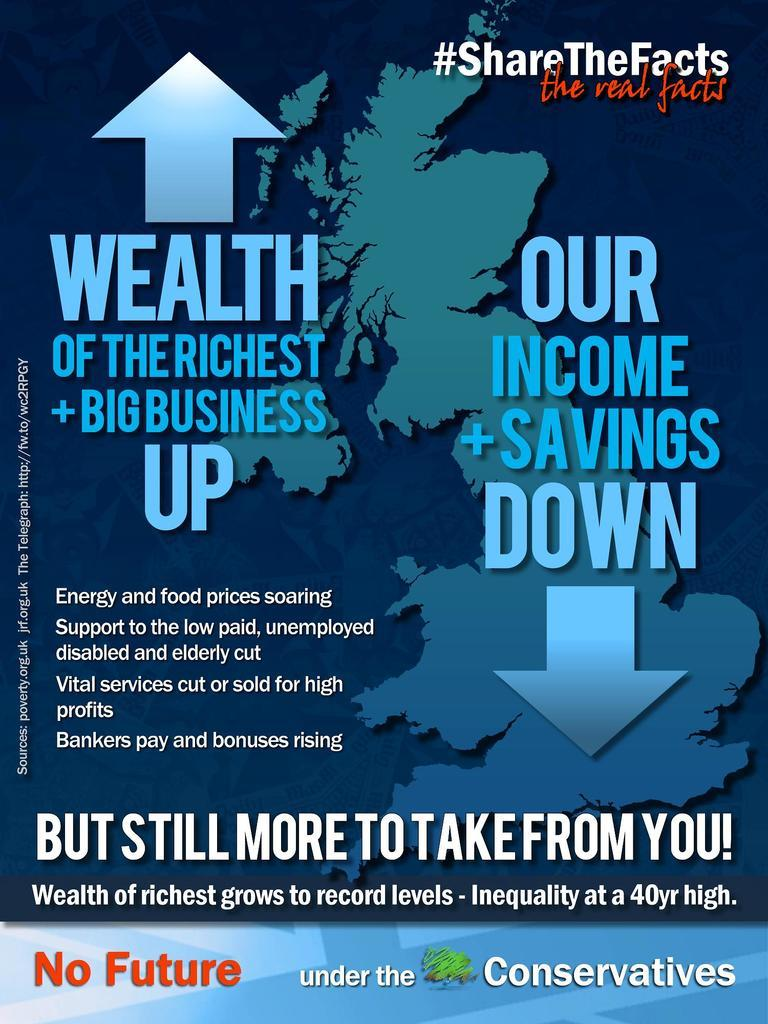What is present in the image that contains information? There is a poster in the image that contains some information. Can you describe the poster in the image? The poster contains information, but the specific details are not mentioned in the provided facts. How many girls are jumping on the poster in the image? There is no mention of girls or jumping in the provided facts, so we cannot answer this question based on the image. 